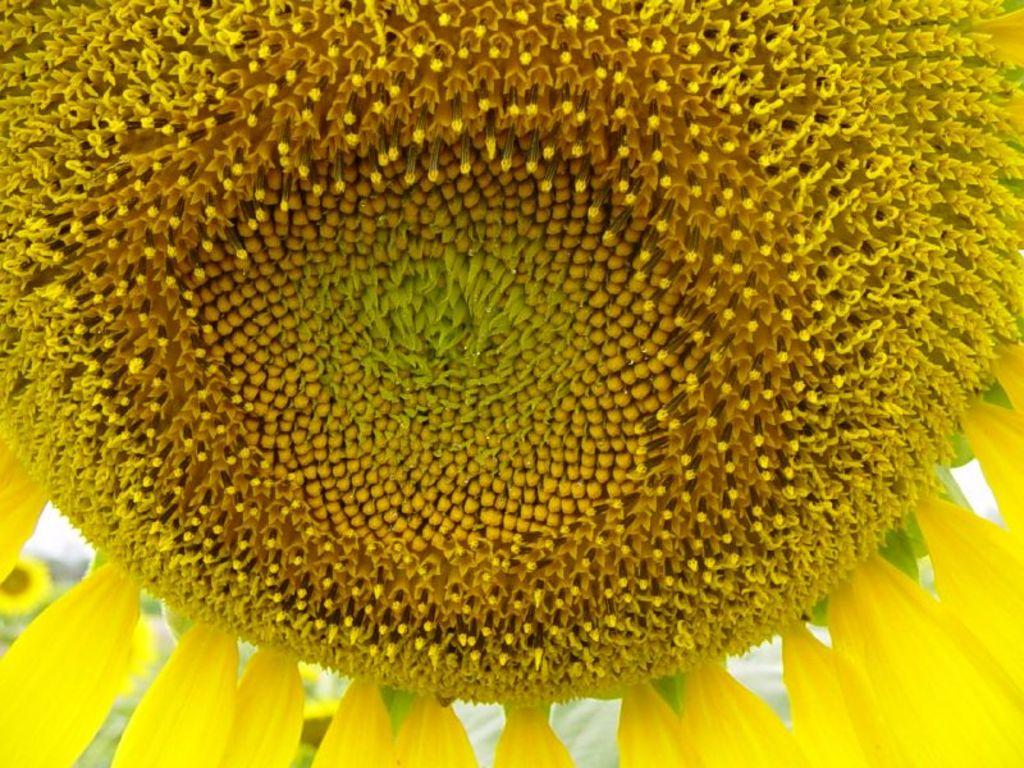What is the main subject of the close-up image? The main subject of the close-up image is a sunflower. What type of winter clothing is visible on the sunflower in the image? There is no winter clothing present in the image, as it features a close-up of a sunflower. How does the sunflower plan to join the upcoming sack race in the image? There is no indication in the image that the sunflower is participating in a sack race or any other event. 